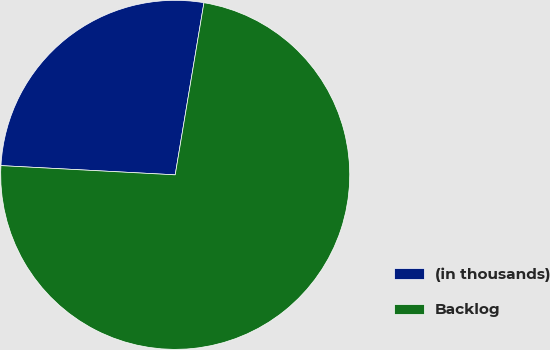<chart> <loc_0><loc_0><loc_500><loc_500><pie_chart><fcel>(in thousands)<fcel>Backlog<nl><fcel>26.79%<fcel>73.21%<nl></chart> 